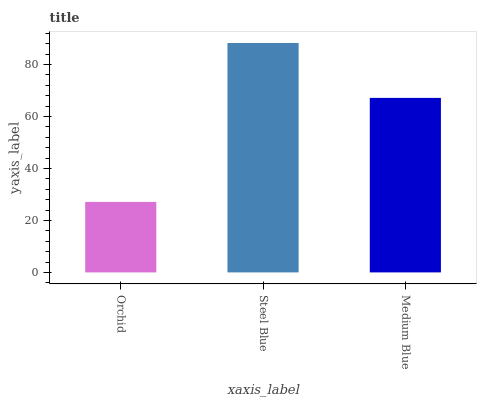Is Orchid the minimum?
Answer yes or no. Yes. Is Steel Blue the maximum?
Answer yes or no. Yes. Is Medium Blue the minimum?
Answer yes or no. No. Is Medium Blue the maximum?
Answer yes or no. No. Is Steel Blue greater than Medium Blue?
Answer yes or no. Yes. Is Medium Blue less than Steel Blue?
Answer yes or no. Yes. Is Medium Blue greater than Steel Blue?
Answer yes or no. No. Is Steel Blue less than Medium Blue?
Answer yes or no. No. Is Medium Blue the high median?
Answer yes or no. Yes. Is Medium Blue the low median?
Answer yes or no. Yes. Is Orchid the high median?
Answer yes or no. No. Is Steel Blue the low median?
Answer yes or no. No. 